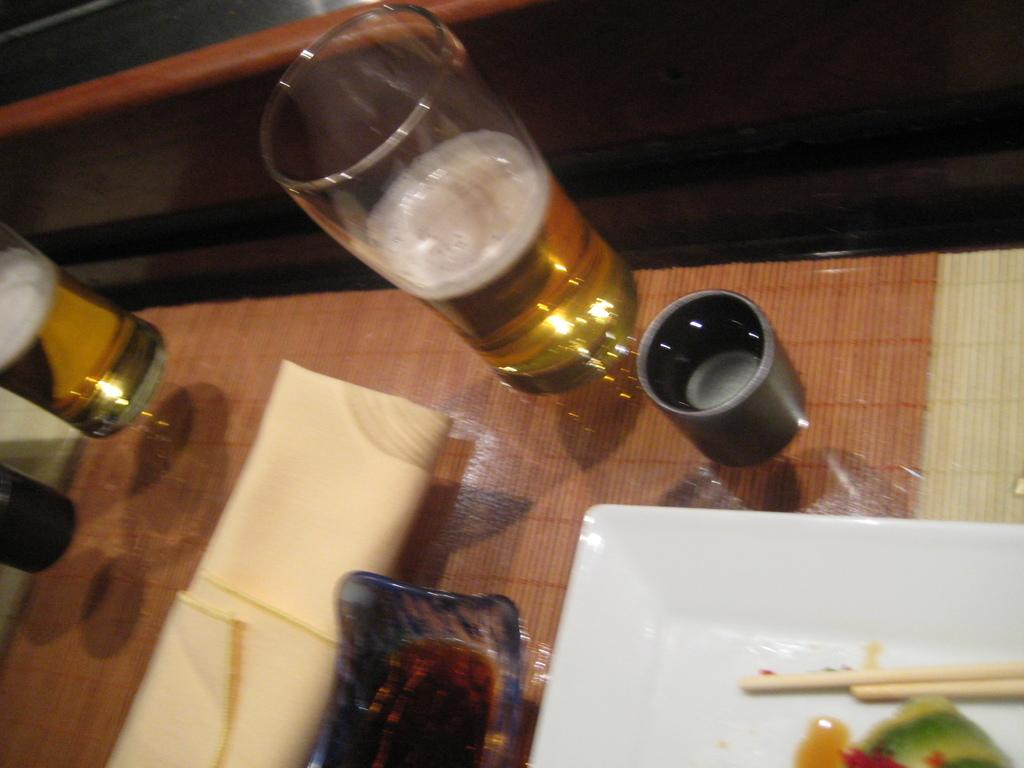How many glasses can be seen in the image? There are two glasses in the image. What else is present in the image besides the glasses? There is a bowl, food on a plate, two chopsticks, a table, and a cream cloth on the table. What is the food on the plate accompanied by? The food on the plate is accompanied by two chopsticks. What is the surface on which the glasses, bowl, and plate are placed? There is a table in the image. What type of cloth is covering the table? There is a cream cloth on the table. How many arms can be seen reaching for the food in the image? There is no indication of any arms reaching for the food in the image. What type of lipstick is being applied to the lip in the image? There is no lip or lipstick present in the image. 